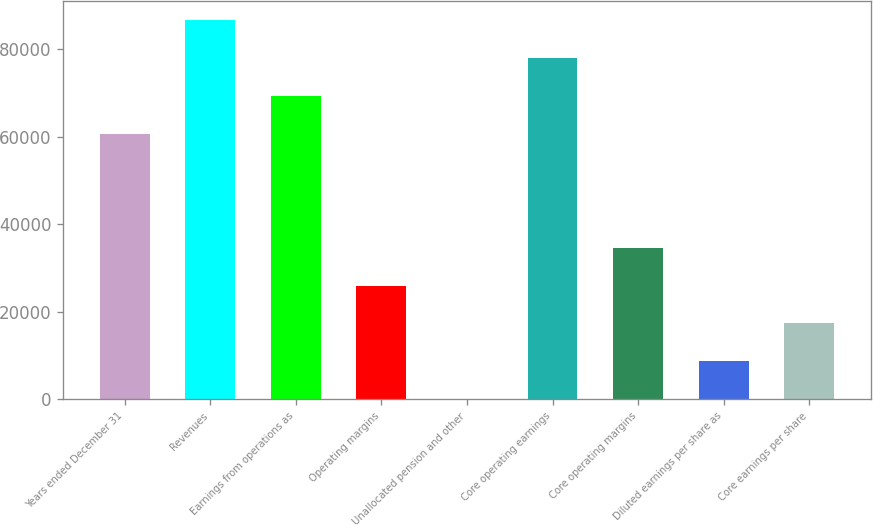Convert chart to OTSL. <chart><loc_0><loc_0><loc_500><loc_500><bar_chart><fcel>Years ended December 31<fcel>Revenues<fcel>Earnings from operations as<fcel>Operating margins<fcel>Unallocated pension and other<fcel>Core operating earnings<fcel>Core operating margins<fcel>Diluted earnings per share as<fcel>Core earnings per share<nl><fcel>60636.4<fcel>86623<fcel>69298.6<fcel>25987.7<fcel>1.11<fcel>77960.8<fcel>34649.9<fcel>8663.3<fcel>17325.5<nl></chart> 